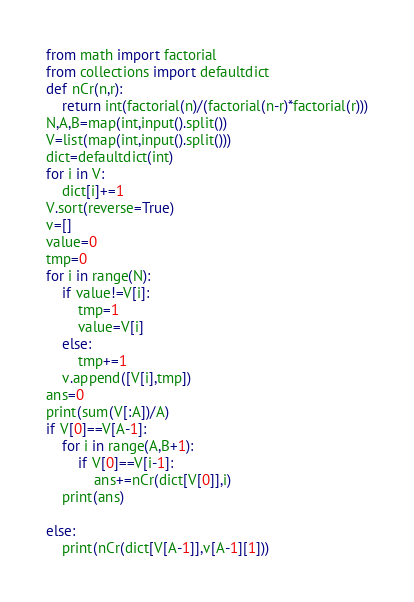<code> <loc_0><loc_0><loc_500><loc_500><_Python_>from math import factorial
from collections import defaultdict
def nCr(n,r):
    return int(factorial(n)/(factorial(n-r)*factorial(r)))
N,A,B=map(int,input().split())
V=list(map(int,input().split()))
dict=defaultdict(int)
for i in V:
    dict[i]+=1
V.sort(reverse=True)
v=[]
value=0
tmp=0
for i in range(N):
    if value!=V[i]:
        tmp=1
        value=V[i]
    else:
        tmp+=1
    v.append([V[i],tmp])
ans=0
print(sum(V[:A])/A)
if V[0]==V[A-1]:
    for i in range(A,B+1):
        if V[0]==V[i-1]:
            ans+=nCr(dict[V[0]],i)
    print(ans)

else:
    print(nCr(dict[V[A-1]],v[A-1][1]))
</code> 